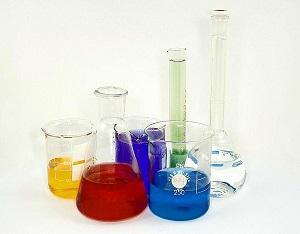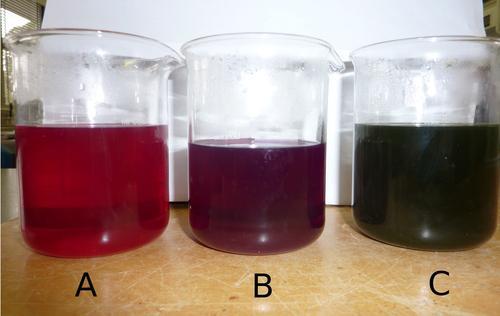The first image is the image on the left, the second image is the image on the right. Given the left and right images, does the statement "All glass vessels contain a non-clear liquid, and one set of beakers shares the same shape." hold true? Answer yes or no. No. The first image is the image on the left, the second image is the image on the right. Examine the images to the left and right. Is the description "The right image contains exactly four flasks." accurate? Answer yes or no. No. 